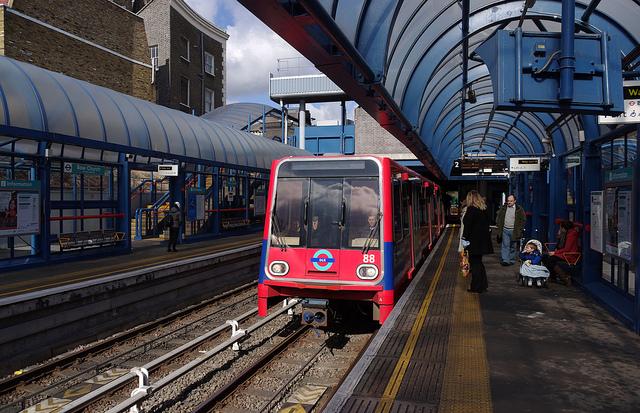What number is on the front of the train?
Quick response, please. 88. What is the weather like in this photo?
Concise answer only. Sunny. What is the little girl wearing?
Write a very short answer. Dress. How many lights are on the front of the train?
Give a very brief answer. 2. How many colors is the train?
Concise answer only. 2. 